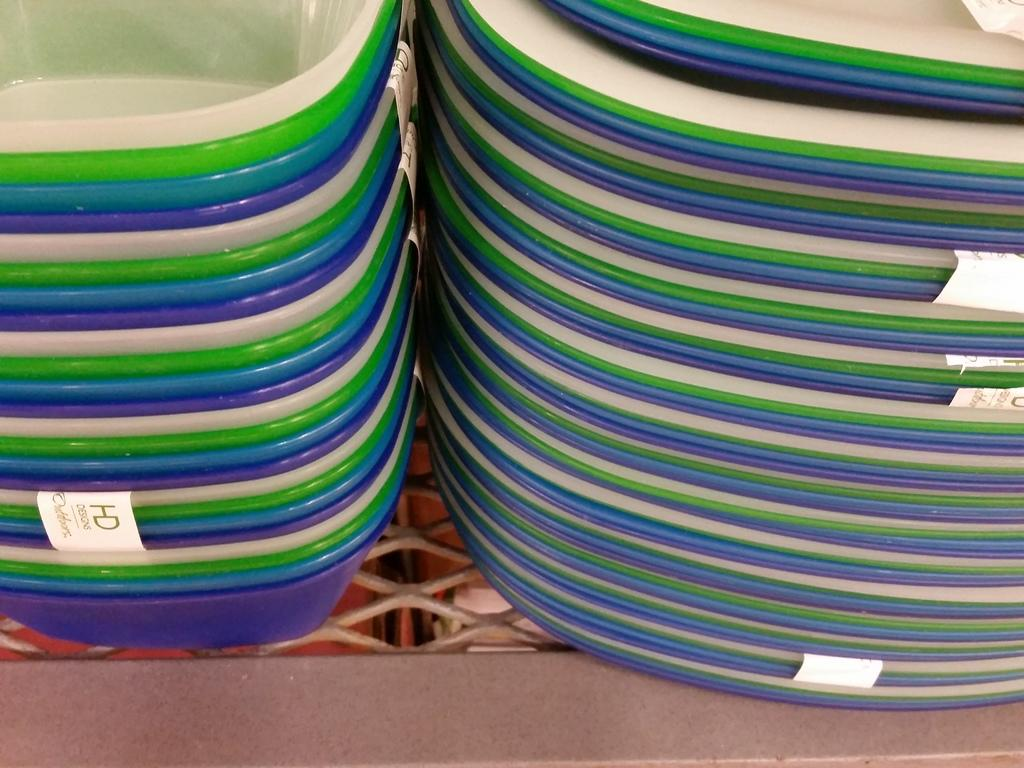What type of dishware is present in the image? There are bowls and plates in the image. What can be observed about the colors of the bowls and plates? The bowls and plates are in different colors. What type of engine can be seen powering the baby in the image? There is no engine or baby present in the image; it only features bowls and plates in different colors. 